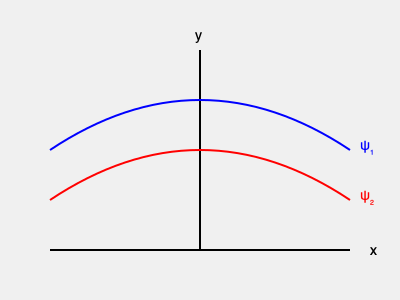In the double-slit experiment, two wavefunctions ψ₁ and ψ₂ are shown in the graph. If these represent the probability amplitudes for a particle passing through each slit, how would you interpret the resulting interference pattern in terms of wave-particle duality? Discuss the implications for the Copenhagen interpretation and any potential alternative explanations. To answer this question, let's break it down step-by-step:

1. Wave-particle duality: The double-slit experiment demonstrates the dual nature of quantum entities. Particles exhibit wave-like behavior when not observed, and particle-like behavior when measured.

2. Probability amplitudes: The wavefunctions ψ₁ and ψ₂ represent the probability amplitudes for the particle passing through each slit. These are complex-valued functions.

3. Interference pattern: The resulting interference pattern is calculated by squaring the absolute value of the sum of these wavefunctions:

   $$P(x) = |\psi_1(x) + \psi_2(x)|^2$$

4. Copenhagen interpretation:
   a) The wavefunction represents the probability amplitude for finding the particle at a given position.
   b) The act of measurement causes the wavefunction to collapse, yielding a definite position.

5. Alternative explanations:
   a) De Broglie-Bohm theory: Proposes that particles have definite positions and are guided by a pilot wave.
   b) Many-worlds interpretation: Suggests that all possible outcomes occur in different, branching universes.

6. Implications:
   a) The interference pattern emerges from the superposition of probability amplitudes, not from actual physical waves.
   b) This challenges classical notions of reality and locality.
   c) The measurement problem remains unresolved: how and why does the wavefunction collapse upon observation?

7. Skepticism of MIT's claim:
   a) Consider potential experimental errors or misinterpretations.
   b) Examine alternative theories that might explain the results without invoking wave-particle duality.
   c) Question the completeness of quantum mechanics as a description of reality.
Answer: The interference pattern results from the superposition of probability amplitudes, challenging classical physics and supporting wave-particle duality. However, alternative interpretations exist, and the measurement problem remains unresolved, warranting continued skepticism and investigation. 